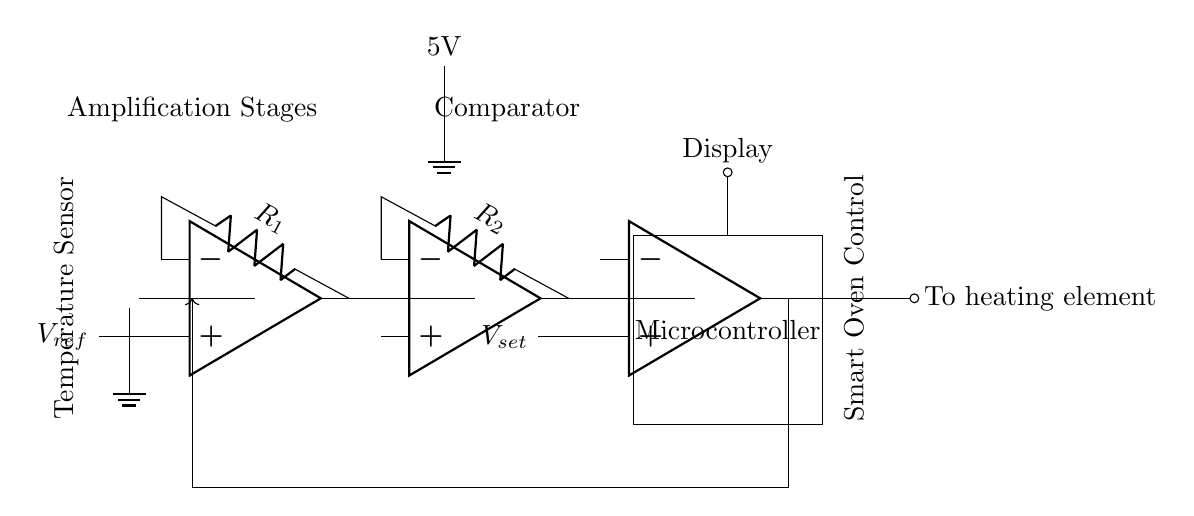What is the type of the temperature sensor used in this circuit? The circuit diagram features a thermistor, labeled as a type of temperature sensor that changes resistance with temperature variations. This can be seen at the starting point of the circuit where the temperature sensor is located.
Answer: thermistor How many amplification stages are present in this circuit? There are three amplification stages indicated by the three operational amplifiers (op amps) labeled op amp 1, op amp 2, and op amp 3. Each op amp represents an amplification stage after the temperature sensor.
Answer: three What is the reference voltage connected to the first op amp? The reference voltage labeled as V reference connects to the non-inverting terminal of the first op amp, indicating that this op amp stage compares the sensor voltage against this reference.
Answer: V reference What is the output of the last op amp connected to? The output of the last op amp connects directly to a component labeled as an output that feeds into the heating element, indicating it controls the heating based on the comparison performed by the op amps.
Answer: heating element Which component regulates the power supply voltage? The circuit diagram shows a battery, labeled as providing a 5V power supply, which supplies voltage to the various components in the circuit. The battery is depicted as the only power source in the circuit.
Answer: 5V What is the purpose of the feedback loop in this circuit? The feedback loop, shown as an arrow looping from the output of the comparator back to the input of the system, is used for maintaining control by sending the output signal back into the system to stabilize or adjust the temperature based on desired settings.
Answer: control stability 